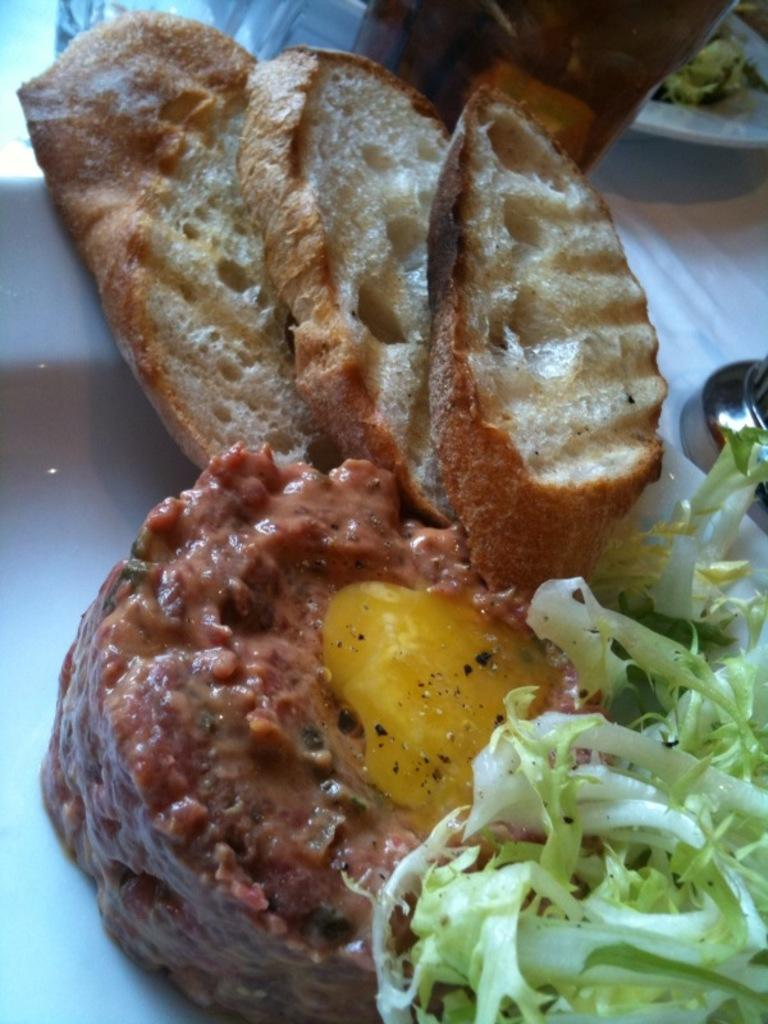What type of food can be seen in the image? The food in the image has brown and green colors. Can you describe the colors of the food? The food has brown and green colors. What else is present at the top of the image? There is a bottle at the top of the image. What type of pear is being used as a quill in the image? There is no pear or quill present in the image. What subject is being taught in the school depicted in the image? There is no school depicted in the image. 